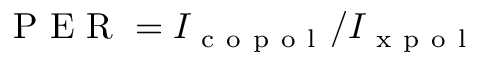Convert formula to latex. <formula><loc_0><loc_0><loc_500><loc_500>P E R = I _ { c o p o l } / I _ { x p o l }</formula> 